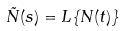Convert formula to latex. <formula><loc_0><loc_0><loc_500><loc_500>\tilde { N } ( s ) = L \{ N ( t ) \}</formula> 